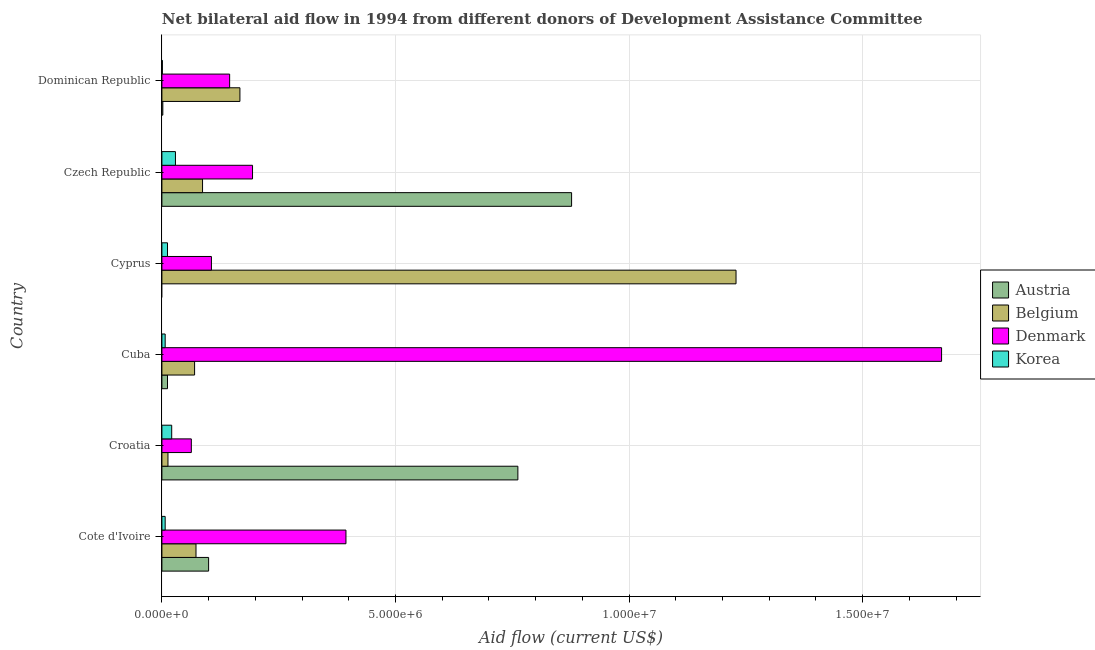Are the number of bars per tick equal to the number of legend labels?
Give a very brief answer. No. Are the number of bars on each tick of the Y-axis equal?
Keep it short and to the point. No. How many bars are there on the 4th tick from the bottom?
Offer a very short reply. 3. What is the label of the 4th group of bars from the top?
Provide a succinct answer. Cuba. What is the amount of aid given by belgium in Cyprus?
Give a very brief answer. 1.23e+07. Across all countries, what is the maximum amount of aid given by belgium?
Provide a succinct answer. 1.23e+07. Across all countries, what is the minimum amount of aid given by belgium?
Make the answer very short. 1.30e+05. In which country was the amount of aid given by korea maximum?
Provide a succinct answer. Czech Republic. What is the total amount of aid given by belgium in the graph?
Offer a very short reply. 1.64e+07. What is the difference between the amount of aid given by belgium in Cote d'Ivoire and that in Czech Republic?
Offer a terse response. -1.40e+05. What is the difference between the amount of aid given by belgium in Croatia and the amount of aid given by denmark in Cote d'Ivoire?
Make the answer very short. -3.81e+06. What is the average amount of aid given by denmark per country?
Give a very brief answer. 4.28e+06. What is the difference between the amount of aid given by denmark and amount of aid given by austria in Cuba?
Offer a very short reply. 1.66e+07. In how many countries, is the amount of aid given by korea greater than 4000000 US$?
Make the answer very short. 0. What is the difference between the highest and the second highest amount of aid given by denmark?
Provide a short and direct response. 1.28e+07. What is the difference between the highest and the lowest amount of aid given by belgium?
Give a very brief answer. 1.22e+07. Is the sum of the amount of aid given by austria in Cote d'Ivoire and Croatia greater than the maximum amount of aid given by belgium across all countries?
Your response must be concise. No. Is it the case that in every country, the sum of the amount of aid given by austria and amount of aid given by denmark is greater than the sum of amount of aid given by korea and amount of aid given by belgium?
Your response must be concise. No. How many countries are there in the graph?
Provide a short and direct response. 6. What is the difference between two consecutive major ticks on the X-axis?
Make the answer very short. 5.00e+06. Are the values on the major ticks of X-axis written in scientific E-notation?
Ensure brevity in your answer.  Yes. Does the graph contain grids?
Provide a short and direct response. Yes. Where does the legend appear in the graph?
Your answer should be very brief. Center right. How many legend labels are there?
Provide a succinct answer. 4. What is the title of the graph?
Provide a short and direct response. Net bilateral aid flow in 1994 from different donors of Development Assistance Committee. What is the label or title of the X-axis?
Provide a short and direct response. Aid flow (current US$). What is the Aid flow (current US$) of Belgium in Cote d'Ivoire?
Offer a very short reply. 7.30e+05. What is the Aid flow (current US$) of Denmark in Cote d'Ivoire?
Your answer should be compact. 3.94e+06. What is the Aid flow (current US$) of Austria in Croatia?
Offer a very short reply. 7.62e+06. What is the Aid flow (current US$) in Belgium in Croatia?
Offer a very short reply. 1.30e+05. What is the Aid flow (current US$) in Denmark in Croatia?
Provide a succinct answer. 6.30e+05. What is the Aid flow (current US$) of Austria in Cuba?
Provide a succinct answer. 1.20e+05. What is the Aid flow (current US$) of Belgium in Cuba?
Keep it short and to the point. 7.00e+05. What is the Aid flow (current US$) of Denmark in Cuba?
Provide a short and direct response. 1.67e+07. What is the Aid flow (current US$) of Korea in Cuba?
Provide a short and direct response. 7.00e+04. What is the Aid flow (current US$) of Belgium in Cyprus?
Provide a succinct answer. 1.23e+07. What is the Aid flow (current US$) in Denmark in Cyprus?
Keep it short and to the point. 1.06e+06. What is the Aid flow (current US$) of Korea in Cyprus?
Provide a succinct answer. 1.20e+05. What is the Aid flow (current US$) of Austria in Czech Republic?
Ensure brevity in your answer.  8.77e+06. What is the Aid flow (current US$) of Belgium in Czech Republic?
Give a very brief answer. 8.70e+05. What is the Aid flow (current US$) of Denmark in Czech Republic?
Your answer should be very brief. 1.94e+06. What is the Aid flow (current US$) in Austria in Dominican Republic?
Your response must be concise. 2.00e+04. What is the Aid flow (current US$) in Belgium in Dominican Republic?
Offer a very short reply. 1.67e+06. What is the Aid flow (current US$) of Denmark in Dominican Republic?
Offer a terse response. 1.45e+06. What is the Aid flow (current US$) of Korea in Dominican Republic?
Provide a succinct answer. 10000. Across all countries, what is the maximum Aid flow (current US$) of Austria?
Provide a succinct answer. 8.77e+06. Across all countries, what is the maximum Aid flow (current US$) of Belgium?
Give a very brief answer. 1.23e+07. Across all countries, what is the maximum Aid flow (current US$) in Denmark?
Your answer should be compact. 1.67e+07. Across all countries, what is the maximum Aid flow (current US$) of Korea?
Offer a terse response. 2.90e+05. Across all countries, what is the minimum Aid flow (current US$) of Austria?
Ensure brevity in your answer.  0. Across all countries, what is the minimum Aid flow (current US$) in Denmark?
Offer a terse response. 6.30e+05. Across all countries, what is the minimum Aid flow (current US$) of Korea?
Offer a terse response. 10000. What is the total Aid flow (current US$) in Austria in the graph?
Give a very brief answer. 1.75e+07. What is the total Aid flow (current US$) of Belgium in the graph?
Offer a very short reply. 1.64e+07. What is the total Aid flow (current US$) of Denmark in the graph?
Provide a short and direct response. 2.57e+07. What is the total Aid flow (current US$) of Korea in the graph?
Provide a succinct answer. 7.70e+05. What is the difference between the Aid flow (current US$) in Austria in Cote d'Ivoire and that in Croatia?
Offer a very short reply. -6.62e+06. What is the difference between the Aid flow (current US$) in Denmark in Cote d'Ivoire and that in Croatia?
Offer a terse response. 3.31e+06. What is the difference between the Aid flow (current US$) in Korea in Cote d'Ivoire and that in Croatia?
Provide a short and direct response. -1.40e+05. What is the difference between the Aid flow (current US$) of Austria in Cote d'Ivoire and that in Cuba?
Make the answer very short. 8.80e+05. What is the difference between the Aid flow (current US$) in Denmark in Cote d'Ivoire and that in Cuba?
Give a very brief answer. -1.28e+07. What is the difference between the Aid flow (current US$) in Belgium in Cote d'Ivoire and that in Cyprus?
Provide a succinct answer. -1.16e+07. What is the difference between the Aid flow (current US$) of Denmark in Cote d'Ivoire and that in Cyprus?
Offer a terse response. 2.88e+06. What is the difference between the Aid flow (current US$) of Austria in Cote d'Ivoire and that in Czech Republic?
Provide a short and direct response. -7.77e+06. What is the difference between the Aid flow (current US$) of Korea in Cote d'Ivoire and that in Czech Republic?
Keep it short and to the point. -2.20e+05. What is the difference between the Aid flow (current US$) in Austria in Cote d'Ivoire and that in Dominican Republic?
Make the answer very short. 9.80e+05. What is the difference between the Aid flow (current US$) of Belgium in Cote d'Ivoire and that in Dominican Republic?
Offer a terse response. -9.40e+05. What is the difference between the Aid flow (current US$) in Denmark in Cote d'Ivoire and that in Dominican Republic?
Ensure brevity in your answer.  2.49e+06. What is the difference between the Aid flow (current US$) of Korea in Cote d'Ivoire and that in Dominican Republic?
Offer a very short reply. 6.00e+04. What is the difference between the Aid flow (current US$) in Austria in Croatia and that in Cuba?
Make the answer very short. 7.50e+06. What is the difference between the Aid flow (current US$) of Belgium in Croatia and that in Cuba?
Give a very brief answer. -5.70e+05. What is the difference between the Aid flow (current US$) in Denmark in Croatia and that in Cuba?
Make the answer very short. -1.61e+07. What is the difference between the Aid flow (current US$) of Korea in Croatia and that in Cuba?
Give a very brief answer. 1.40e+05. What is the difference between the Aid flow (current US$) of Belgium in Croatia and that in Cyprus?
Your answer should be compact. -1.22e+07. What is the difference between the Aid flow (current US$) in Denmark in Croatia and that in Cyprus?
Give a very brief answer. -4.30e+05. What is the difference between the Aid flow (current US$) of Korea in Croatia and that in Cyprus?
Your response must be concise. 9.00e+04. What is the difference between the Aid flow (current US$) of Austria in Croatia and that in Czech Republic?
Provide a succinct answer. -1.15e+06. What is the difference between the Aid flow (current US$) of Belgium in Croatia and that in Czech Republic?
Offer a terse response. -7.40e+05. What is the difference between the Aid flow (current US$) in Denmark in Croatia and that in Czech Republic?
Your answer should be compact. -1.31e+06. What is the difference between the Aid flow (current US$) of Korea in Croatia and that in Czech Republic?
Provide a succinct answer. -8.00e+04. What is the difference between the Aid flow (current US$) of Austria in Croatia and that in Dominican Republic?
Ensure brevity in your answer.  7.60e+06. What is the difference between the Aid flow (current US$) of Belgium in Croatia and that in Dominican Republic?
Offer a very short reply. -1.54e+06. What is the difference between the Aid flow (current US$) of Denmark in Croatia and that in Dominican Republic?
Provide a short and direct response. -8.20e+05. What is the difference between the Aid flow (current US$) of Belgium in Cuba and that in Cyprus?
Keep it short and to the point. -1.16e+07. What is the difference between the Aid flow (current US$) in Denmark in Cuba and that in Cyprus?
Provide a succinct answer. 1.56e+07. What is the difference between the Aid flow (current US$) in Austria in Cuba and that in Czech Republic?
Provide a succinct answer. -8.65e+06. What is the difference between the Aid flow (current US$) of Denmark in Cuba and that in Czech Republic?
Your answer should be very brief. 1.48e+07. What is the difference between the Aid flow (current US$) of Austria in Cuba and that in Dominican Republic?
Make the answer very short. 1.00e+05. What is the difference between the Aid flow (current US$) in Belgium in Cuba and that in Dominican Republic?
Your response must be concise. -9.70e+05. What is the difference between the Aid flow (current US$) of Denmark in Cuba and that in Dominican Republic?
Make the answer very short. 1.52e+07. What is the difference between the Aid flow (current US$) of Korea in Cuba and that in Dominican Republic?
Offer a terse response. 6.00e+04. What is the difference between the Aid flow (current US$) of Belgium in Cyprus and that in Czech Republic?
Provide a succinct answer. 1.14e+07. What is the difference between the Aid flow (current US$) of Denmark in Cyprus and that in Czech Republic?
Offer a terse response. -8.80e+05. What is the difference between the Aid flow (current US$) in Korea in Cyprus and that in Czech Republic?
Provide a short and direct response. -1.70e+05. What is the difference between the Aid flow (current US$) in Belgium in Cyprus and that in Dominican Republic?
Your answer should be compact. 1.06e+07. What is the difference between the Aid flow (current US$) in Denmark in Cyprus and that in Dominican Republic?
Provide a succinct answer. -3.90e+05. What is the difference between the Aid flow (current US$) in Austria in Czech Republic and that in Dominican Republic?
Ensure brevity in your answer.  8.75e+06. What is the difference between the Aid flow (current US$) in Belgium in Czech Republic and that in Dominican Republic?
Provide a short and direct response. -8.00e+05. What is the difference between the Aid flow (current US$) in Denmark in Czech Republic and that in Dominican Republic?
Offer a very short reply. 4.90e+05. What is the difference between the Aid flow (current US$) in Austria in Cote d'Ivoire and the Aid flow (current US$) in Belgium in Croatia?
Your response must be concise. 8.70e+05. What is the difference between the Aid flow (current US$) in Austria in Cote d'Ivoire and the Aid flow (current US$) in Korea in Croatia?
Your answer should be compact. 7.90e+05. What is the difference between the Aid flow (current US$) in Belgium in Cote d'Ivoire and the Aid flow (current US$) in Denmark in Croatia?
Provide a succinct answer. 1.00e+05. What is the difference between the Aid flow (current US$) in Belgium in Cote d'Ivoire and the Aid flow (current US$) in Korea in Croatia?
Your response must be concise. 5.20e+05. What is the difference between the Aid flow (current US$) of Denmark in Cote d'Ivoire and the Aid flow (current US$) of Korea in Croatia?
Offer a very short reply. 3.73e+06. What is the difference between the Aid flow (current US$) in Austria in Cote d'Ivoire and the Aid flow (current US$) in Denmark in Cuba?
Provide a succinct answer. -1.57e+07. What is the difference between the Aid flow (current US$) in Austria in Cote d'Ivoire and the Aid flow (current US$) in Korea in Cuba?
Give a very brief answer. 9.30e+05. What is the difference between the Aid flow (current US$) in Belgium in Cote d'Ivoire and the Aid flow (current US$) in Denmark in Cuba?
Ensure brevity in your answer.  -1.60e+07. What is the difference between the Aid flow (current US$) in Denmark in Cote d'Ivoire and the Aid flow (current US$) in Korea in Cuba?
Offer a terse response. 3.87e+06. What is the difference between the Aid flow (current US$) of Austria in Cote d'Ivoire and the Aid flow (current US$) of Belgium in Cyprus?
Your response must be concise. -1.13e+07. What is the difference between the Aid flow (current US$) of Austria in Cote d'Ivoire and the Aid flow (current US$) of Denmark in Cyprus?
Make the answer very short. -6.00e+04. What is the difference between the Aid flow (current US$) in Austria in Cote d'Ivoire and the Aid flow (current US$) in Korea in Cyprus?
Keep it short and to the point. 8.80e+05. What is the difference between the Aid flow (current US$) in Belgium in Cote d'Ivoire and the Aid flow (current US$) in Denmark in Cyprus?
Offer a terse response. -3.30e+05. What is the difference between the Aid flow (current US$) of Denmark in Cote d'Ivoire and the Aid flow (current US$) of Korea in Cyprus?
Offer a terse response. 3.82e+06. What is the difference between the Aid flow (current US$) in Austria in Cote d'Ivoire and the Aid flow (current US$) in Belgium in Czech Republic?
Offer a very short reply. 1.30e+05. What is the difference between the Aid flow (current US$) in Austria in Cote d'Ivoire and the Aid flow (current US$) in Denmark in Czech Republic?
Give a very brief answer. -9.40e+05. What is the difference between the Aid flow (current US$) of Austria in Cote d'Ivoire and the Aid flow (current US$) of Korea in Czech Republic?
Ensure brevity in your answer.  7.10e+05. What is the difference between the Aid flow (current US$) of Belgium in Cote d'Ivoire and the Aid flow (current US$) of Denmark in Czech Republic?
Give a very brief answer. -1.21e+06. What is the difference between the Aid flow (current US$) in Denmark in Cote d'Ivoire and the Aid flow (current US$) in Korea in Czech Republic?
Provide a succinct answer. 3.65e+06. What is the difference between the Aid flow (current US$) in Austria in Cote d'Ivoire and the Aid flow (current US$) in Belgium in Dominican Republic?
Your answer should be very brief. -6.70e+05. What is the difference between the Aid flow (current US$) in Austria in Cote d'Ivoire and the Aid flow (current US$) in Denmark in Dominican Republic?
Your answer should be very brief. -4.50e+05. What is the difference between the Aid flow (current US$) in Austria in Cote d'Ivoire and the Aid flow (current US$) in Korea in Dominican Republic?
Give a very brief answer. 9.90e+05. What is the difference between the Aid flow (current US$) of Belgium in Cote d'Ivoire and the Aid flow (current US$) of Denmark in Dominican Republic?
Your answer should be very brief. -7.20e+05. What is the difference between the Aid flow (current US$) of Belgium in Cote d'Ivoire and the Aid flow (current US$) of Korea in Dominican Republic?
Offer a very short reply. 7.20e+05. What is the difference between the Aid flow (current US$) in Denmark in Cote d'Ivoire and the Aid flow (current US$) in Korea in Dominican Republic?
Offer a very short reply. 3.93e+06. What is the difference between the Aid flow (current US$) of Austria in Croatia and the Aid flow (current US$) of Belgium in Cuba?
Offer a very short reply. 6.92e+06. What is the difference between the Aid flow (current US$) of Austria in Croatia and the Aid flow (current US$) of Denmark in Cuba?
Provide a succinct answer. -9.07e+06. What is the difference between the Aid flow (current US$) of Austria in Croatia and the Aid flow (current US$) of Korea in Cuba?
Make the answer very short. 7.55e+06. What is the difference between the Aid flow (current US$) in Belgium in Croatia and the Aid flow (current US$) in Denmark in Cuba?
Ensure brevity in your answer.  -1.66e+07. What is the difference between the Aid flow (current US$) of Denmark in Croatia and the Aid flow (current US$) of Korea in Cuba?
Your answer should be very brief. 5.60e+05. What is the difference between the Aid flow (current US$) in Austria in Croatia and the Aid flow (current US$) in Belgium in Cyprus?
Keep it short and to the point. -4.67e+06. What is the difference between the Aid flow (current US$) of Austria in Croatia and the Aid flow (current US$) of Denmark in Cyprus?
Give a very brief answer. 6.56e+06. What is the difference between the Aid flow (current US$) in Austria in Croatia and the Aid flow (current US$) in Korea in Cyprus?
Offer a terse response. 7.50e+06. What is the difference between the Aid flow (current US$) of Belgium in Croatia and the Aid flow (current US$) of Denmark in Cyprus?
Keep it short and to the point. -9.30e+05. What is the difference between the Aid flow (current US$) of Belgium in Croatia and the Aid flow (current US$) of Korea in Cyprus?
Offer a terse response. 10000. What is the difference between the Aid flow (current US$) of Denmark in Croatia and the Aid flow (current US$) of Korea in Cyprus?
Offer a very short reply. 5.10e+05. What is the difference between the Aid flow (current US$) of Austria in Croatia and the Aid flow (current US$) of Belgium in Czech Republic?
Provide a succinct answer. 6.75e+06. What is the difference between the Aid flow (current US$) in Austria in Croatia and the Aid flow (current US$) in Denmark in Czech Republic?
Your response must be concise. 5.68e+06. What is the difference between the Aid flow (current US$) of Austria in Croatia and the Aid flow (current US$) of Korea in Czech Republic?
Ensure brevity in your answer.  7.33e+06. What is the difference between the Aid flow (current US$) of Belgium in Croatia and the Aid flow (current US$) of Denmark in Czech Republic?
Make the answer very short. -1.81e+06. What is the difference between the Aid flow (current US$) of Denmark in Croatia and the Aid flow (current US$) of Korea in Czech Republic?
Your answer should be compact. 3.40e+05. What is the difference between the Aid flow (current US$) of Austria in Croatia and the Aid flow (current US$) of Belgium in Dominican Republic?
Your response must be concise. 5.95e+06. What is the difference between the Aid flow (current US$) in Austria in Croatia and the Aid flow (current US$) in Denmark in Dominican Republic?
Give a very brief answer. 6.17e+06. What is the difference between the Aid flow (current US$) of Austria in Croatia and the Aid flow (current US$) of Korea in Dominican Republic?
Keep it short and to the point. 7.61e+06. What is the difference between the Aid flow (current US$) in Belgium in Croatia and the Aid flow (current US$) in Denmark in Dominican Republic?
Your response must be concise. -1.32e+06. What is the difference between the Aid flow (current US$) in Belgium in Croatia and the Aid flow (current US$) in Korea in Dominican Republic?
Keep it short and to the point. 1.20e+05. What is the difference between the Aid flow (current US$) of Denmark in Croatia and the Aid flow (current US$) of Korea in Dominican Republic?
Keep it short and to the point. 6.20e+05. What is the difference between the Aid flow (current US$) of Austria in Cuba and the Aid flow (current US$) of Belgium in Cyprus?
Your answer should be very brief. -1.22e+07. What is the difference between the Aid flow (current US$) in Austria in Cuba and the Aid flow (current US$) in Denmark in Cyprus?
Your response must be concise. -9.40e+05. What is the difference between the Aid flow (current US$) of Austria in Cuba and the Aid flow (current US$) of Korea in Cyprus?
Ensure brevity in your answer.  0. What is the difference between the Aid flow (current US$) of Belgium in Cuba and the Aid flow (current US$) of Denmark in Cyprus?
Your response must be concise. -3.60e+05. What is the difference between the Aid flow (current US$) of Belgium in Cuba and the Aid flow (current US$) of Korea in Cyprus?
Make the answer very short. 5.80e+05. What is the difference between the Aid flow (current US$) in Denmark in Cuba and the Aid flow (current US$) in Korea in Cyprus?
Offer a terse response. 1.66e+07. What is the difference between the Aid flow (current US$) of Austria in Cuba and the Aid flow (current US$) of Belgium in Czech Republic?
Ensure brevity in your answer.  -7.50e+05. What is the difference between the Aid flow (current US$) in Austria in Cuba and the Aid flow (current US$) in Denmark in Czech Republic?
Provide a succinct answer. -1.82e+06. What is the difference between the Aid flow (current US$) in Austria in Cuba and the Aid flow (current US$) in Korea in Czech Republic?
Keep it short and to the point. -1.70e+05. What is the difference between the Aid flow (current US$) of Belgium in Cuba and the Aid flow (current US$) of Denmark in Czech Republic?
Provide a succinct answer. -1.24e+06. What is the difference between the Aid flow (current US$) of Belgium in Cuba and the Aid flow (current US$) of Korea in Czech Republic?
Offer a terse response. 4.10e+05. What is the difference between the Aid flow (current US$) in Denmark in Cuba and the Aid flow (current US$) in Korea in Czech Republic?
Keep it short and to the point. 1.64e+07. What is the difference between the Aid flow (current US$) in Austria in Cuba and the Aid flow (current US$) in Belgium in Dominican Republic?
Provide a short and direct response. -1.55e+06. What is the difference between the Aid flow (current US$) in Austria in Cuba and the Aid flow (current US$) in Denmark in Dominican Republic?
Provide a succinct answer. -1.33e+06. What is the difference between the Aid flow (current US$) of Austria in Cuba and the Aid flow (current US$) of Korea in Dominican Republic?
Give a very brief answer. 1.10e+05. What is the difference between the Aid flow (current US$) of Belgium in Cuba and the Aid flow (current US$) of Denmark in Dominican Republic?
Offer a terse response. -7.50e+05. What is the difference between the Aid flow (current US$) of Belgium in Cuba and the Aid flow (current US$) of Korea in Dominican Republic?
Give a very brief answer. 6.90e+05. What is the difference between the Aid flow (current US$) of Denmark in Cuba and the Aid flow (current US$) of Korea in Dominican Republic?
Ensure brevity in your answer.  1.67e+07. What is the difference between the Aid flow (current US$) of Belgium in Cyprus and the Aid flow (current US$) of Denmark in Czech Republic?
Ensure brevity in your answer.  1.04e+07. What is the difference between the Aid flow (current US$) of Denmark in Cyprus and the Aid flow (current US$) of Korea in Czech Republic?
Keep it short and to the point. 7.70e+05. What is the difference between the Aid flow (current US$) in Belgium in Cyprus and the Aid flow (current US$) in Denmark in Dominican Republic?
Provide a succinct answer. 1.08e+07. What is the difference between the Aid flow (current US$) in Belgium in Cyprus and the Aid flow (current US$) in Korea in Dominican Republic?
Offer a very short reply. 1.23e+07. What is the difference between the Aid flow (current US$) in Denmark in Cyprus and the Aid flow (current US$) in Korea in Dominican Republic?
Offer a very short reply. 1.05e+06. What is the difference between the Aid flow (current US$) in Austria in Czech Republic and the Aid flow (current US$) in Belgium in Dominican Republic?
Provide a short and direct response. 7.10e+06. What is the difference between the Aid flow (current US$) of Austria in Czech Republic and the Aid flow (current US$) of Denmark in Dominican Republic?
Provide a succinct answer. 7.32e+06. What is the difference between the Aid flow (current US$) of Austria in Czech Republic and the Aid flow (current US$) of Korea in Dominican Republic?
Give a very brief answer. 8.76e+06. What is the difference between the Aid flow (current US$) in Belgium in Czech Republic and the Aid flow (current US$) in Denmark in Dominican Republic?
Offer a terse response. -5.80e+05. What is the difference between the Aid flow (current US$) of Belgium in Czech Republic and the Aid flow (current US$) of Korea in Dominican Republic?
Your response must be concise. 8.60e+05. What is the difference between the Aid flow (current US$) in Denmark in Czech Republic and the Aid flow (current US$) in Korea in Dominican Republic?
Make the answer very short. 1.93e+06. What is the average Aid flow (current US$) in Austria per country?
Ensure brevity in your answer.  2.92e+06. What is the average Aid flow (current US$) in Belgium per country?
Give a very brief answer. 2.73e+06. What is the average Aid flow (current US$) of Denmark per country?
Give a very brief answer. 4.28e+06. What is the average Aid flow (current US$) of Korea per country?
Ensure brevity in your answer.  1.28e+05. What is the difference between the Aid flow (current US$) of Austria and Aid flow (current US$) of Belgium in Cote d'Ivoire?
Give a very brief answer. 2.70e+05. What is the difference between the Aid flow (current US$) in Austria and Aid flow (current US$) in Denmark in Cote d'Ivoire?
Provide a succinct answer. -2.94e+06. What is the difference between the Aid flow (current US$) in Austria and Aid flow (current US$) in Korea in Cote d'Ivoire?
Your response must be concise. 9.30e+05. What is the difference between the Aid flow (current US$) in Belgium and Aid flow (current US$) in Denmark in Cote d'Ivoire?
Your answer should be very brief. -3.21e+06. What is the difference between the Aid flow (current US$) in Denmark and Aid flow (current US$) in Korea in Cote d'Ivoire?
Give a very brief answer. 3.87e+06. What is the difference between the Aid flow (current US$) of Austria and Aid flow (current US$) of Belgium in Croatia?
Ensure brevity in your answer.  7.49e+06. What is the difference between the Aid flow (current US$) of Austria and Aid flow (current US$) of Denmark in Croatia?
Provide a short and direct response. 6.99e+06. What is the difference between the Aid flow (current US$) in Austria and Aid flow (current US$) in Korea in Croatia?
Offer a very short reply. 7.41e+06. What is the difference between the Aid flow (current US$) of Belgium and Aid flow (current US$) of Denmark in Croatia?
Keep it short and to the point. -5.00e+05. What is the difference between the Aid flow (current US$) of Belgium and Aid flow (current US$) of Korea in Croatia?
Provide a succinct answer. -8.00e+04. What is the difference between the Aid flow (current US$) in Austria and Aid flow (current US$) in Belgium in Cuba?
Your answer should be compact. -5.80e+05. What is the difference between the Aid flow (current US$) of Austria and Aid flow (current US$) of Denmark in Cuba?
Keep it short and to the point. -1.66e+07. What is the difference between the Aid flow (current US$) of Austria and Aid flow (current US$) of Korea in Cuba?
Ensure brevity in your answer.  5.00e+04. What is the difference between the Aid flow (current US$) of Belgium and Aid flow (current US$) of Denmark in Cuba?
Your answer should be compact. -1.60e+07. What is the difference between the Aid flow (current US$) in Belgium and Aid flow (current US$) in Korea in Cuba?
Your answer should be compact. 6.30e+05. What is the difference between the Aid flow (current US$) of Denmark and Aid flow (current US$) of Korea in Cuba?
Your response must be concise. 1.66e+07. What is the difference between the Aid flow (current US$) in Belgium and Aid flow (current US$) in Denmark in Cyprus?
Your response must be concise. 1.12e+07. What is the difference between the Aid flow (current US$) in Belgium and Aid flow (current US$) in Korea in Cyprus?
Offer a terse response. 1.22e+07. What is the difference between the Aid flow (current US$) of Denmark and Aid flow (current US$) of Korea in Cyprus?
Ensure brevity in your answer.  9.40e+05. What is the difference between the Aid flow (current US$) in Austria and Aid flow (current US$) in Belgium in Czech Republic?
Provide a short and direct response. 7.90e+06. What is the difference between the Aid flow (current US$) in Austria and Aid flow (current US$) in Denmark in Czech Republic?
Offer a terse response. 6.83e+06. What is the difference between the Aid flow (current US$) of Austria and Aid flow (current US$) of Korea in Czech Republic?
Provide a succinct answer. 8.48e+06. What is the difference between the Aid flow (current US$) of Belgium and Aid flow (current US$) of Denmark in Czech Republic?
Your answer should be compact. -1.07e+06. What is the difference between the Aid flow (current US$) in Belgium and Aid flow (current US$) in Korea in Czech Republic?
Your response must be concise. 5.80e+05. What is the difference between the Aid flow (current US$) of Denmark and Aid flow (current US$) of Korea in Czech Republic?
Ensure brevity in your answer.  1.65e+06. What is the difference between the Aid flow (current US$) of Austria and Aid flow (current US$) of Belgium in Dominican Republic?
Your answer should be very brief. -1.65e+06. What is the difference between the Aid flow (current US$) in Austria and Aid flow (current US$) in Denmark in Dominican Republic?
Ensure brevity in your answer.  -1.43e+06. What is the difference between the Aid flow (current US$) of Belgium and Aid flow (current US$) of Denmark in Dominican Republic?
Your answer should be compact. 2.20e+05. What is the difference between the Aid flow (current US$) in Belgium and Aid flow (current US$) in Korea in Dominican Republic?
Give a very brief answer. 1.66e+06. What is the difference between the Aid flow (current US$) in Denmark and Aid flow (current US$) in Korea in Dominican Republic?
Keep it short and to the point. 1.44e+06. What is the ratio of the Aid flow (current US$) in Austria in Cote d'Ivoire to that in Croatia?
Keep it short and to the point. 0.13. What is the ratio of the Aid flow (current US$) in Belgium in Cote d'Ivoire to that in Croatia?
Offer a very short reply. 5.62. What is the ratio of the Aid flow (current US$) in Denmark in Cote d'Ivoire to that in Croatia?
Your response must be concise. 6.25. What is the ratio of the Aid flow (current US$) in Austria in Cote d'Ivoire to that in Cuba?
Offer a terse response. 8.33. What is the ratio of the Aid flow (current US$) of Belgium in Cote d'Ivoire to that in Cuba?
Your response must be concise. 1.04. What is the ratio of the Aid flow (current US$) of Denmark in Cote d'Ivoire to that in Cuba?
Give a very brief answer. 0.24. What is the ratio of the Aid flow (current US$) in Belgium in Cote d'Ivoire to that in Cyprus?
Make the answer very short. 0.06. What is the ratio of the Aid flow (current US$) of Denmark in Cote d'Ivoire to that in Cyprus?
Provide a short and direct response. 3.72. What is the ratio of the Aid flow (current US$) of Korea in Cote d'Ivoire to that in Cyprus?
Your answer should be very brief. 0.58. What is the ratio of the Aid flow (current US$) of Austria in Cote d'Ivoire to that in Czech Republic?
Your answer should be very brief. 0.11. What is the ratio of the Aid flow (current US$) in Belgium in Cote d'Ivoire to that in Czech Republic?
Provide a succinct answer. 0.84. What is the ratio of the Aid flow (current US$) in Denmark in Cote d'Ivoire to that in Czech Republic?
Your answer should be compact. 2.03. What is the ratio of the Aid flow (current US$) of Korea in Cote d'Ivoire to that in Czech Republic?
Give a very brief answer. 0.24. What is the ratio of the Aid flow (current US$) in Austria in Cote d'Ivoire to that in Dominican Republic?
Offer a terse response. 50. What is the ratio of the Aid flow (current US$) of Belgium in Cote d'Ivoire to that in Dominican Republic?
Your answer should be compact. 0.44. What is the ratio of the Aid flow (current US$) of Denmark in Cote d'Ivoire to that in Dominican Republic?
Provide a succinct answer. 2.72. What is the ratio of the Aid flow (current US$) in Austria in Croatia to that in Cuba?
Ensure brevity in your answer.  63.5. What is the ratio of the Aid flow (current US$) of Belgium in Croatia to that in Cuba?
Keep it short and to the point. 0.19. What is the ratio of the Aid flow (current US$) of Denmark in Croatia to that in Cuba?
Your answer should be compact. 0.04. What is the ratio of the Aid flow (current US$) in Belgium in Croatia to that in Cyprus?
Provide a short and direct response. 0.01. What is the ratio of the Aid flow (current US$) of Denmark in Croatia to that in Cyprus?
Offer a very short reply. 0.59. What is the ratio of the Aid flow (current US$) of Korea in Croatia to that in Cyprus?
Ensure brevity in your answer.  1.75. What is the ratio of the Aid flow (current US$) in Austria in Croatia to that in Czech Republic?
Offer a very short reply. 0.87. What is the ratio of the Aid flow (current US$) in Belgium in Croatia to that in Czech Republic?
Provide a succinct answer. 0.15. What is the ratio of the Aid flow (current US$) in Denmark in Croatia to that in Czech Republic?
Offer a terse response. 0.32. What is the ratio of the Aid flow (current US$) of Korea in Croatia to that in Czech Republic?
Your answer should be compact. 0.72. What is the ratio of the Aid flow (current US$) of Austria in Croatia to that in Dominican Republic?
Ensure brevity in your answer.  381. What is the ratio of the Aid flow (current US$) of Belgium in Croatia to that in Dominican Republic?
Your response must be concise. 0.08. What is the ratio of the Aid flow (current US$) of Denmark in Croatia to that in Dominican Republic?
Offer a very short reply. 0.43. What is the ratio of the Aid flow (current US$) of Belgium in Cuba to that in Cyprus?
Provide a succinct answer. 0.06. What is the ratio of the Aid flow (current US$) of Denmark in Cuba to that in Cyprus?
Offer a very short reply. 15.75. What is the ratio of the Aid flow (current US$) in Korea in Cuba to that in Cyprus?
Keep it short and to the point. 0.58. What is the ratio of the Aid flow (current US$) in Austria in Cuba to that in Czech Republic?
Offer a terse response. 0.01. What is the ratio of the Aid flow (current US$) in Belgium in Cuba to that in Czech Republic?
Provide a succinct answer. 0.8. What is the ratio of the Aid flow (current US$) in Denmark in Cuba to that in Czech Republic?
Keep it short and to the point. 8.6. What is the ratio of the Aid flow (current US$) in Korea in Cuba to that in Czech Republic?
Provide a short and direct response. 0.24. What is the ratio of the Aid flow (current US$) of Belgium in Cuba to that in Dominican Republic?
Make the answer very short. 0.42. What is the ratio of the Aid flow (current US$) in Denmark in Cuba to that in Dominican Republic?
Offer a very short reply. 11.51. What is the ratio of the Aid flow (current US$) in Belgium in Cyprus to that in Czech Republic?
Provide a succinct answer. 14.13. What is the ratio of the Aid flow (current US$) of Denmark in Cyprus to that in Czech Republic?
Provide a short and direct response. 0.55. What is the ratio of the Aid flow (current US$) in Korea in Cyprus to that in Czech Republic?
Your answer should be very brief. 0.41. What is the ratio of the Aid flow (current US$) of Belgium in Cyprus to that in Dominican Republic?
Your response must be concise. 7.36. What is the ratio of the Aid flow (current US$) in Denmark in Cyprus to that in Dominican Republic?
Your answer should be very brief. 0.73. What is the ratio of the Aid flow (current US$) in Korea in Cyprus to that in Dominican Republic?
Give a very brief answer. 12. What is the ratio of the Aid flow (current US$) in Austria in Czech Republic to that in Dominican Republic?
Your response must be concise. 438.5. What is the ratio of the Aid flow (current US$) of Belgium in Czech Republic to that in Dominican Republic?
Offer a very short reply. 0.52. What is the ratio of the Aid flow (current US$) in Denmark in Czech Republic to that in Dominican Republic?
Provide a short and direct response. 1.34. What is the ratio of the Aid flow (current US$) in Korea in Czech Republic to that in Dominican Republic?
Provide a short and direct response. 29. What is the difference between the highest and the second highest Aid flow (current US$) in Austria?
Provide a succinct answer. 1.15e+06. What is the difference between the highest and the second highest Aid flow (current US$) of Belgium?
Your response must be concise. 1.06e+07. What is the difference between the highest and the second highest Aid flow (current US$) of Denmark?
Ensure brevity in your answer.  1.28e+07. What is the difference between the highest and the second highest Aid flow (current US$) of Korea?
Your response must be concise. 8.00e+04. What is the difference between the highest and the lowest Aid flow (current US$) of Austria?
Ensure brevity in your answer.  8.77e+06. What is the difference between the highest and the lowest Aid flow (current US$) in Belgium?
Your answer should be compact. 1.22e+07. What is the difference between the highest and the lowest Aid flow (current US$) of Denmark?
Make the answer very short. 1.61e+07. 